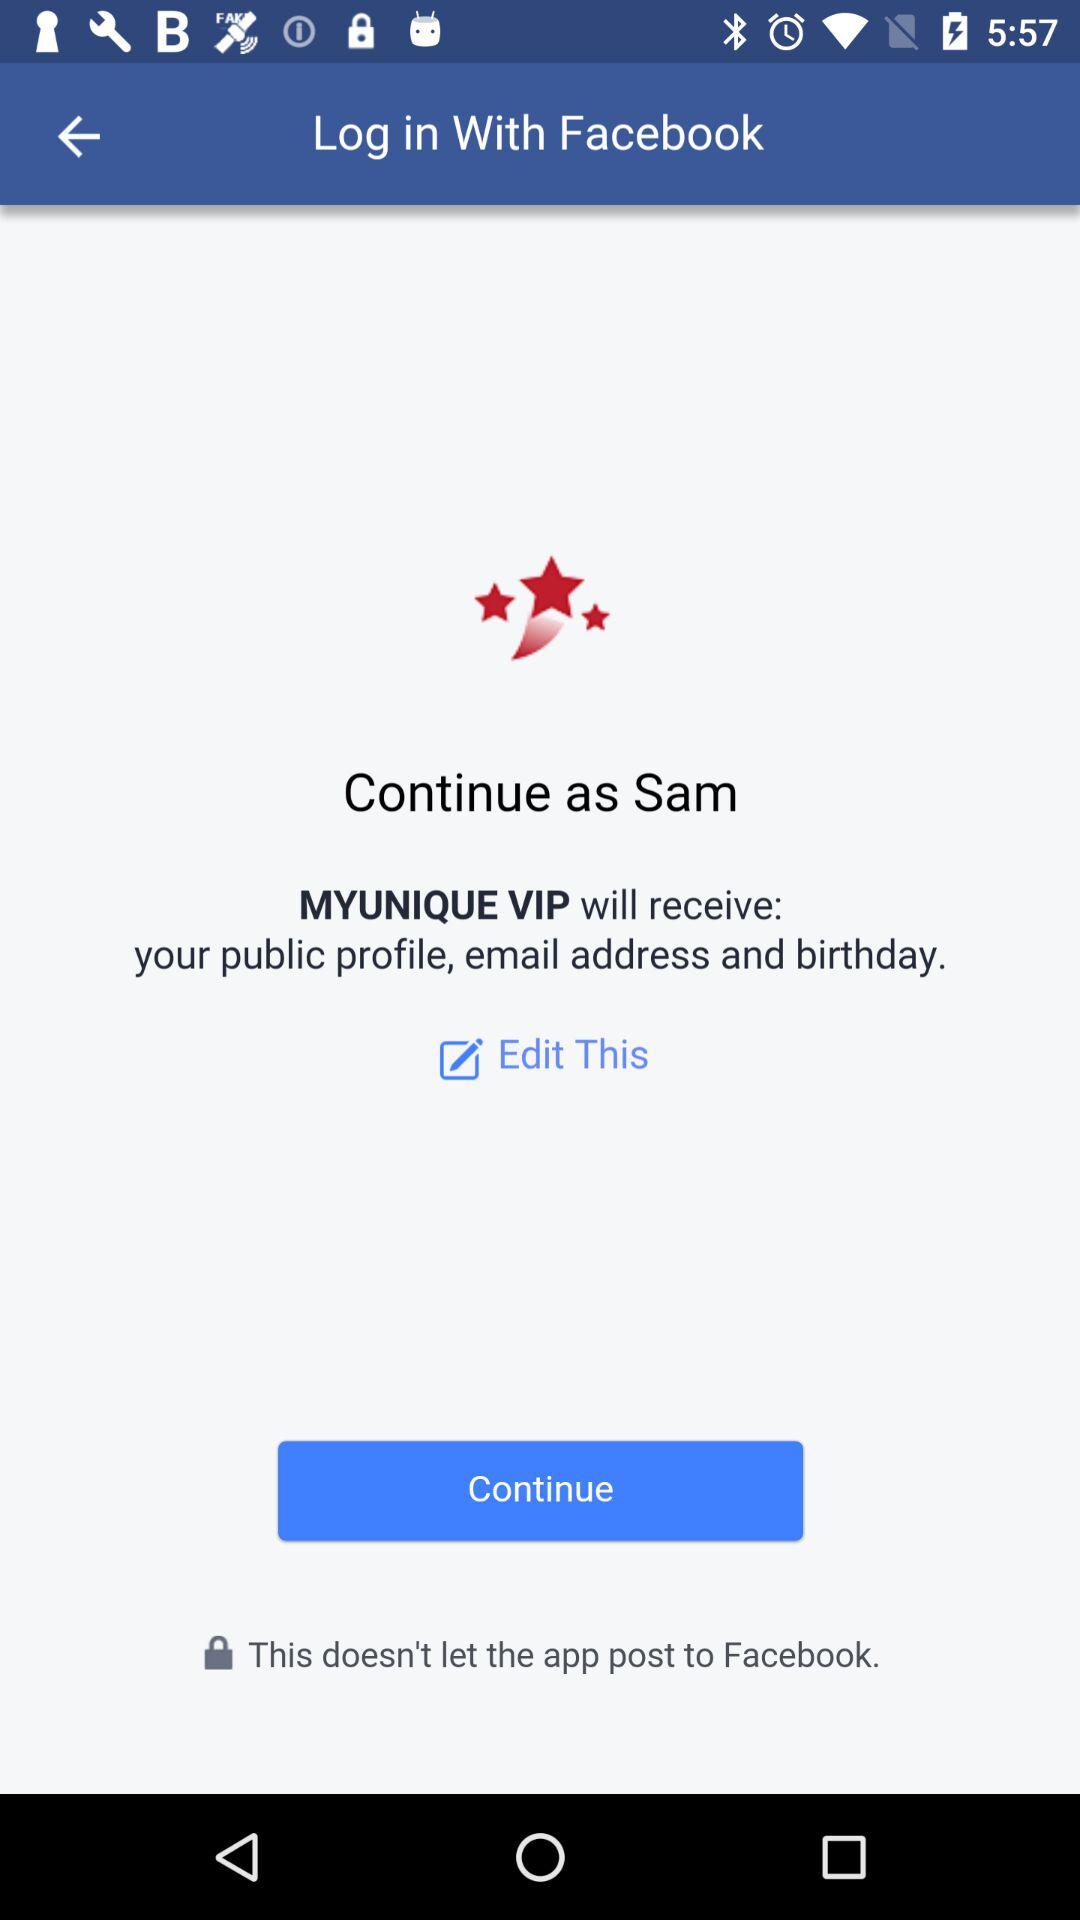What is the user name? The user name is Sam. 